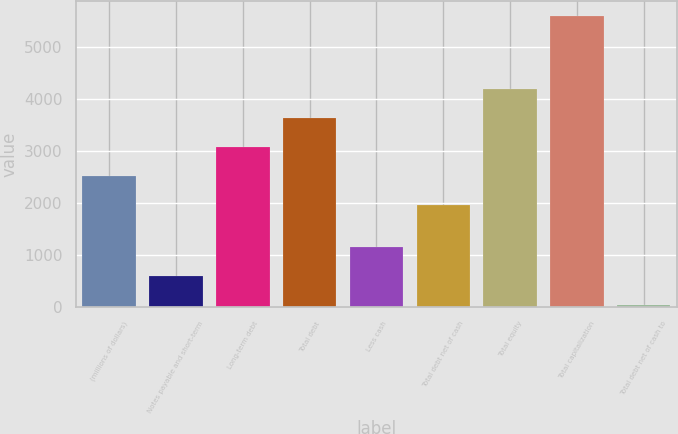<chart> <loc_0><loc_0><loc_500><loc_500><bar_chart><fcel>(millions of dollars)<fcel>Notes payable and short-term<fcel>Long-term debt<fcel>Total debt<fcel>Less cash<fcel>Total debt net of cash<fcel>Total equity<fcel>Total capitalization<fcel>Total debt net of cash to<nl><fcel>2529.49<fcel>592.09<fcel>3086.38<fcel>3643.27<fcel>1148.98<fcel>1972.6<fcel>4200.16<fcel>5604.1<fcel>35.2<nl></chart> 